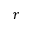<formula> <loc_0><loc_0><loc_500><loc_500>r</formula> 